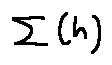Convert formula to latex. <formula><loc_0><loc_0><loc_500><loc_500>\sum [ h ]</formula> 